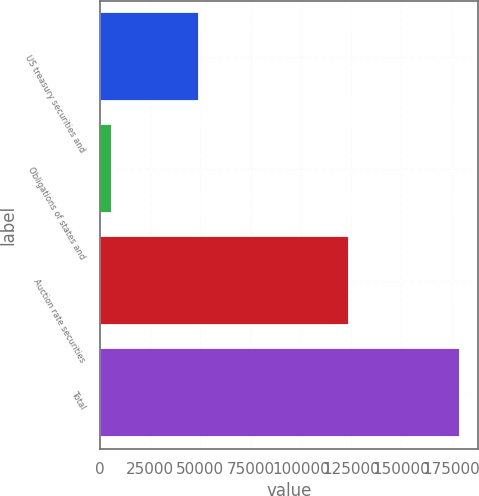Convert chart. <chart><loc_0><loc_0><loc_500><loc_500><bar_chart><fcel>US treasury securities and<fcel>Obligations of states and<fcel>Auction rate securities<fcel>Total<nl><fcel>49533<fcel>6047<fcel>123789<fcel>179369<nl></chart> 